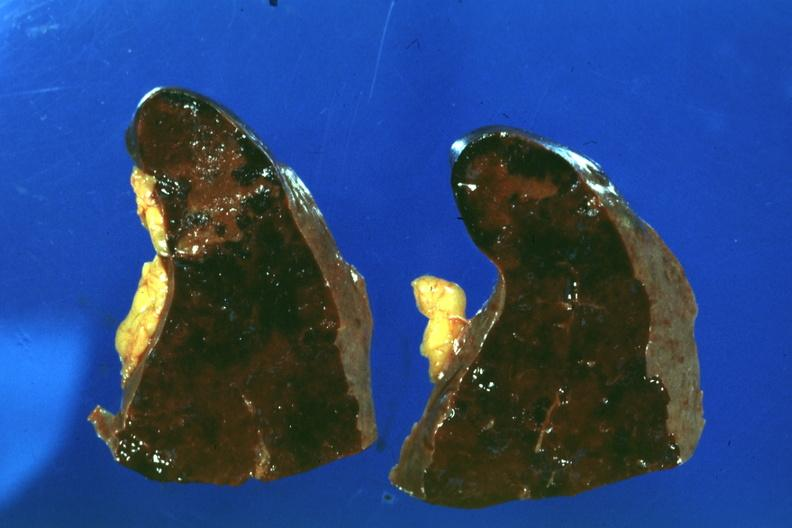where is this part in?
Answer the question using a single word or phrase. Spleen 